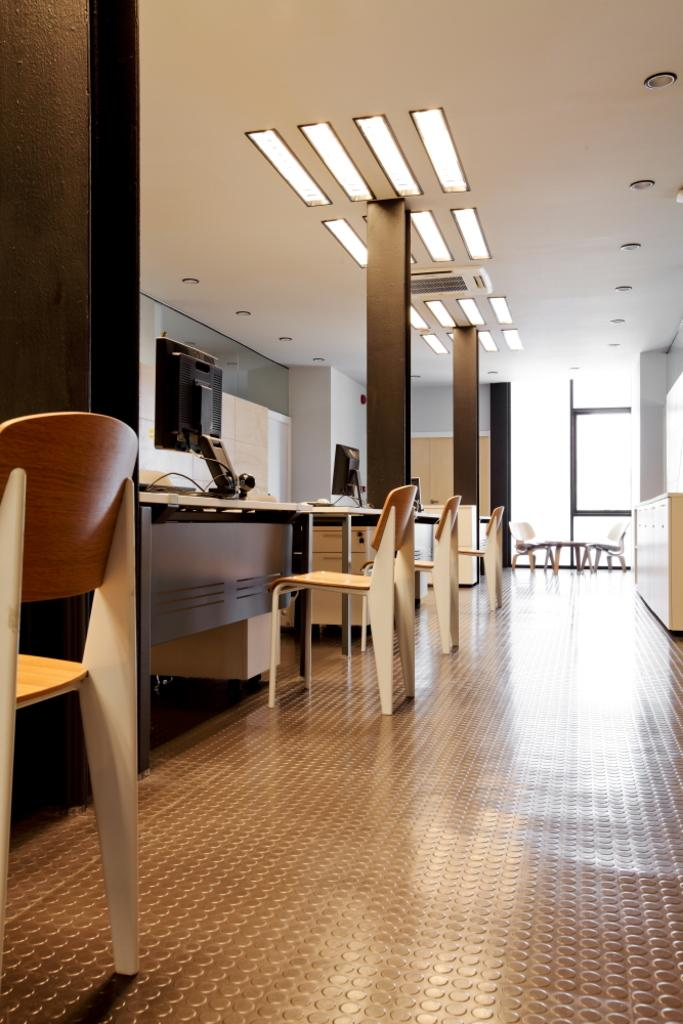What type of furniture is present in the image? There are chairs and tables in the image. What is placed on the tables? There are monitors on the tables. What can be seen on the ceiling in the image? There are lights on the ceiling. What type of yam is being used as a decoration on the tables in the image? There is no yam present in the image; the tables have monitors on them. Can you see any animals in the image? There are no animals present in the image. 